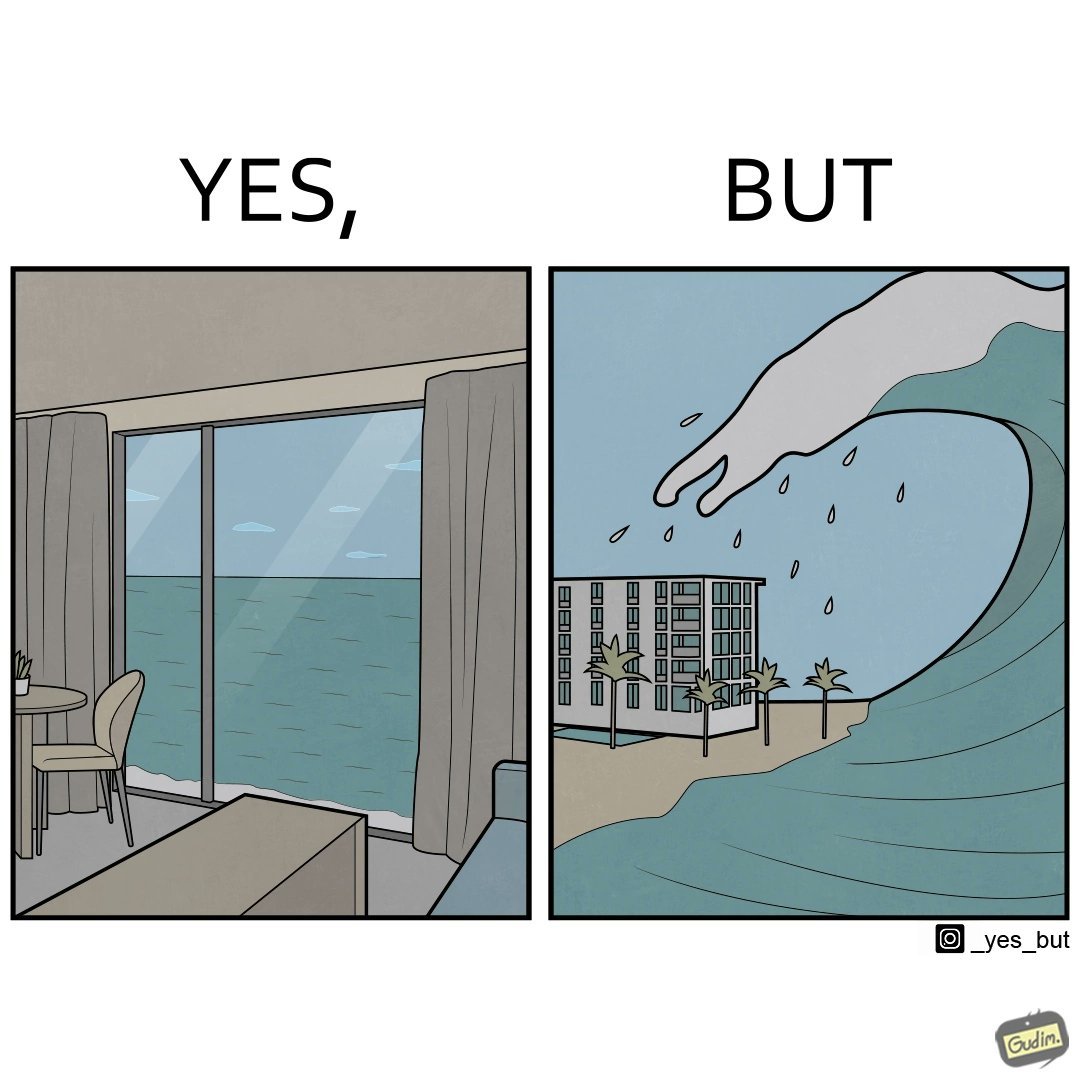Describe what you see in the left and right parts of this image. In the left part of the image: a room with a sea-facing door In the right part of the image: high waves in the sea twice of the height of the building near the sea 